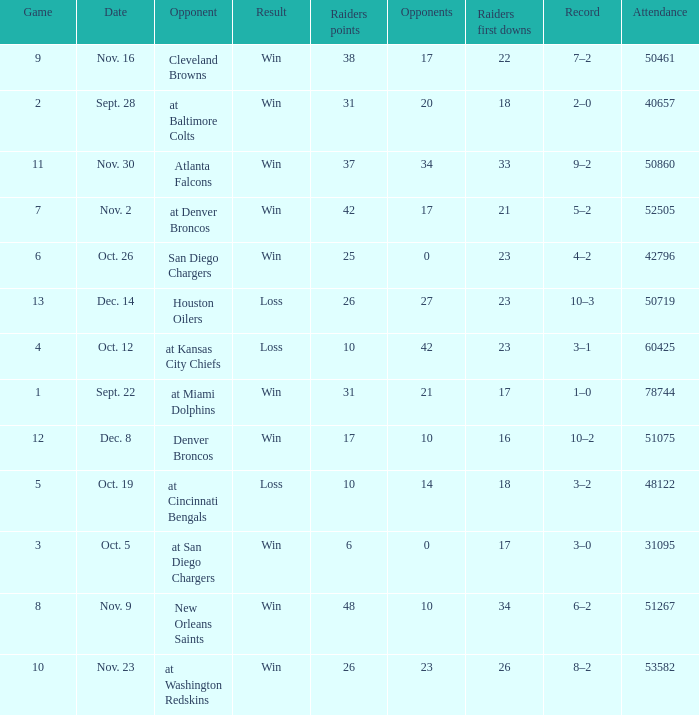Parse the full table. {'header': ['Game', 'Date', 'Opponent', 'Result', 'Raiders points', 'Opponents', 'Raiders first downs', 'Record', 'Attendance'], 'rows': [['9', 'Nov. 16', 'Cleveland Browns', 'Win', '38', '17', '22', '7–2', '50461'], ['2', 'Sept. 28', 'at Baltimore Colts', 'Win', '31', '20', '18', '2–0', '40657'], ['11', 'Nov. 30', 'Atlanta Falcons', 'Win', '37', '34', '33', '9–2', '50860'], ['7', 'Nov. 2', 'at Denver Broncos', 'Win', '42', '17', '21', '5–2', '52505'], ['6', 'Oct. 26', 'San Diego Chargers', 'Win', '25', '0', '23', '4–2', '42796'], ['13', 'Dec. 14', 'Houston Oilers', 'Loss', '26', '27', '23', '10–3', '50719'], ['4', 'Oct. 12', 'at Kansas City Chiefs', 'Loss', '10', '42', '23', '3–1', '60425'], ['1', 'Sept. 22', 'at Miami Dolphins', 'Win', '31', '21', '17', '1–0', '78744'], ['12', 'Dec. 8', 'Denver Broncos', 'Win', '17', '10', '16', '10–2', '51075'], ['5', 'Oct. 19', 'at Cincinnati Bengals', 'Loss', '10', '14', '18', '3–2', '48122'], ['3', 'Oct. 5', 'at San Diego Chargers', 'Win', '6', '0', '17', '3–0', '31095'], ['8', 'Nov. 9', 'New Orleans Saints', 'Win', '48', '10', '34', '6–2', '51267'], ['10', 'Nov. 23', 'at Washington Redskins', 'Win', '26', '23', '26', '8–2', '53582']]} How many opponents played 1 game with a result win? 21.0. 